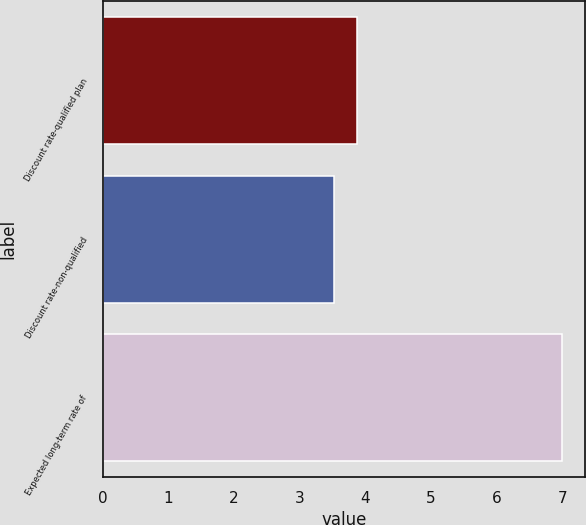Convert chart. <chart><loc_0><loc_0><loc_500><loc_500><bar_chart><fcel>Discount rate-qualified plan<fcel>Discount rate-non-qualified<fcel>Expected long-term rate of<nl><fcel>3.88<fcel>3.53<fcel>7<nl></chart> 